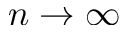Convert formula to latex. <formula><loc_0><loc_0><loc_500><loc_500>n \rightarrow \infty</formula> 